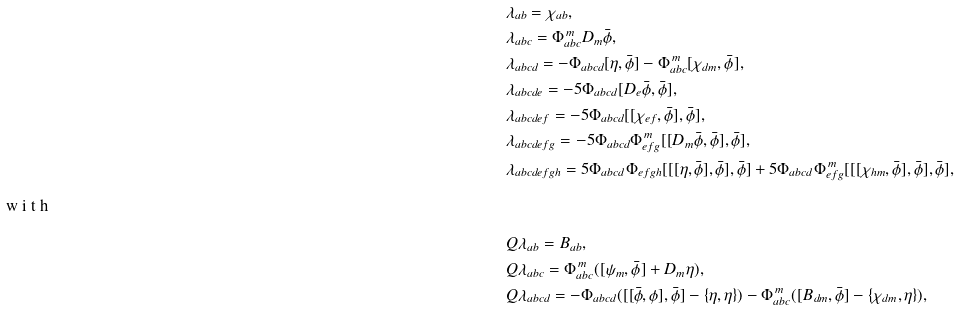Convert formula to latex. <formula><loc_0><loc_0><loc_500><loc_500>& \lambda _ { a b } = \chi _ { a b } , \\ & \lambda _ { a b c } = \Phi _ { a b c } ^ { \, m } D _ { m } \bar { \phi } , \\ & \lambda _ { a b c d } = - \Phi _ { a b c d } [ \eta , \bar { \phi } ] - \Phi _ { a b c } ^ { \, m } [ \chi _ { d m } , \bar { \phi } ] , \\ & \lambda _ { a b c d e } = - 5 \Phi _ { a b c d } [ D _ { e } \bar { \phi } , \bar { \phi } ] , \\ & \lambda _ { a b c d e f } = - 5 \Phi _ { a b c d } [ [ \chi _ { e f } , \bar { \phi } ] , \bar { \phi } ] , \\ & \lambda _ { a b c d e f g } = - 5 \Phi _ { a b c d } \Phi _ { e f g } ^ { \, m } [ [ D _ { m } \bar { \phi } , \bar { \phi } ] , \bar { \phi } ] , \\ & \lambda _ { a b c d e f g h } = 5 \Phi _ { a b c d } \Phi _ { e f g h } [ [ [ \eta , \bar { \phi } ] , \bar { \phi } ] , \bar { \phi } ] + 5 \Phi _ { a b c d } \Phi _ { e f g } ^ { \, m } [ [ [ \chi _ { h m } , \bar { \phi } ] , \bar { \phi } ] , \bar { \phi } ] , \\ \intertext { w i t h } & Q \lambda _ { a b } = B _ { a b } , \\ & Q \lambda _ { a b c } = \Phi _ { a b c } ^ { \, m } ( [ \psi _ { m } , \bar { \phi } ] + D _ { m } \eta ) , \\ & Q \lambda _ { a b c d } = - \Phi _ { a b c d } ( [ [ \bar { \phi } , \phi ] , \bar { \phi } ] - \{ \eta , \eta \} ) - \Phi _ { a b c } ^ { \, m } ( [ B _ { d m } , \bar { \phi } ] - \{ \chi _ { d m } , \eta \} ) ,</formula> 